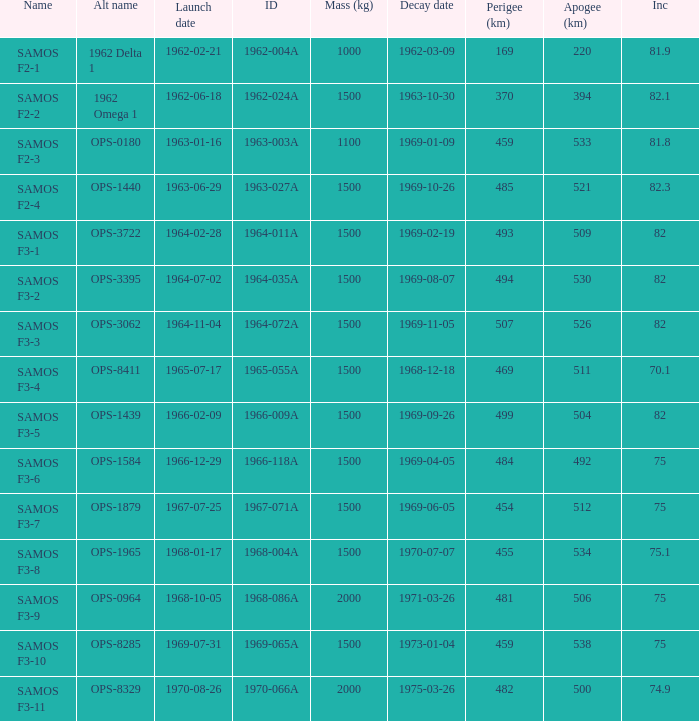How many alt names does 1964-011a have? 1.0. 